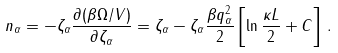Convert formula to latex. <formula><loc_0><loc_0><loc_500><loc_500>n _ { \alpha } = - \zeta _ { \alpha } \frac { \partial ( \beta \Omega / V ) } { \partial \zeta _ { \alpha } } = \zeta _ { \alpha } - \zeta _ { \alpha } \frac { \beta q _ { \alpha } ^ { 2 } } { 2 } \left [ \ln \frac { \kappa L } { 2 } + C \right ] \, .</formula> 